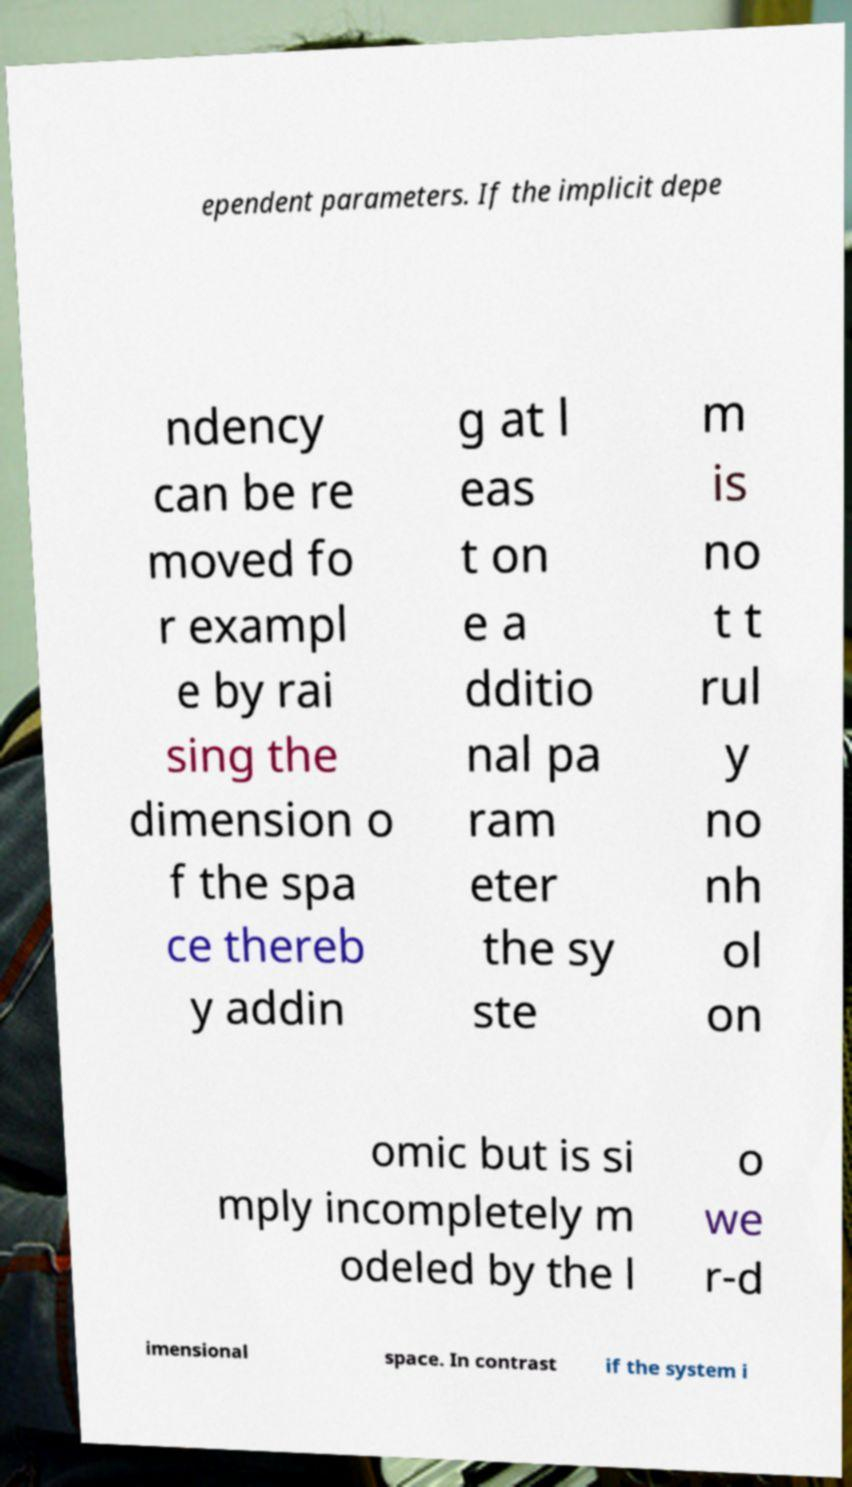Could you extract and type out the text from this image? ependent parameters. If the implicit depe ndency can be re moved fo r exampl e by rai sing the dimension o f the spa ce thereb y addin g at l eas t on e a dditio nal pa ram eter the sy ste m is no t t rul y no nh ol on omic but is si mply incompletely m odeled by the l o we r-d imensional space. In contrast if the system i 